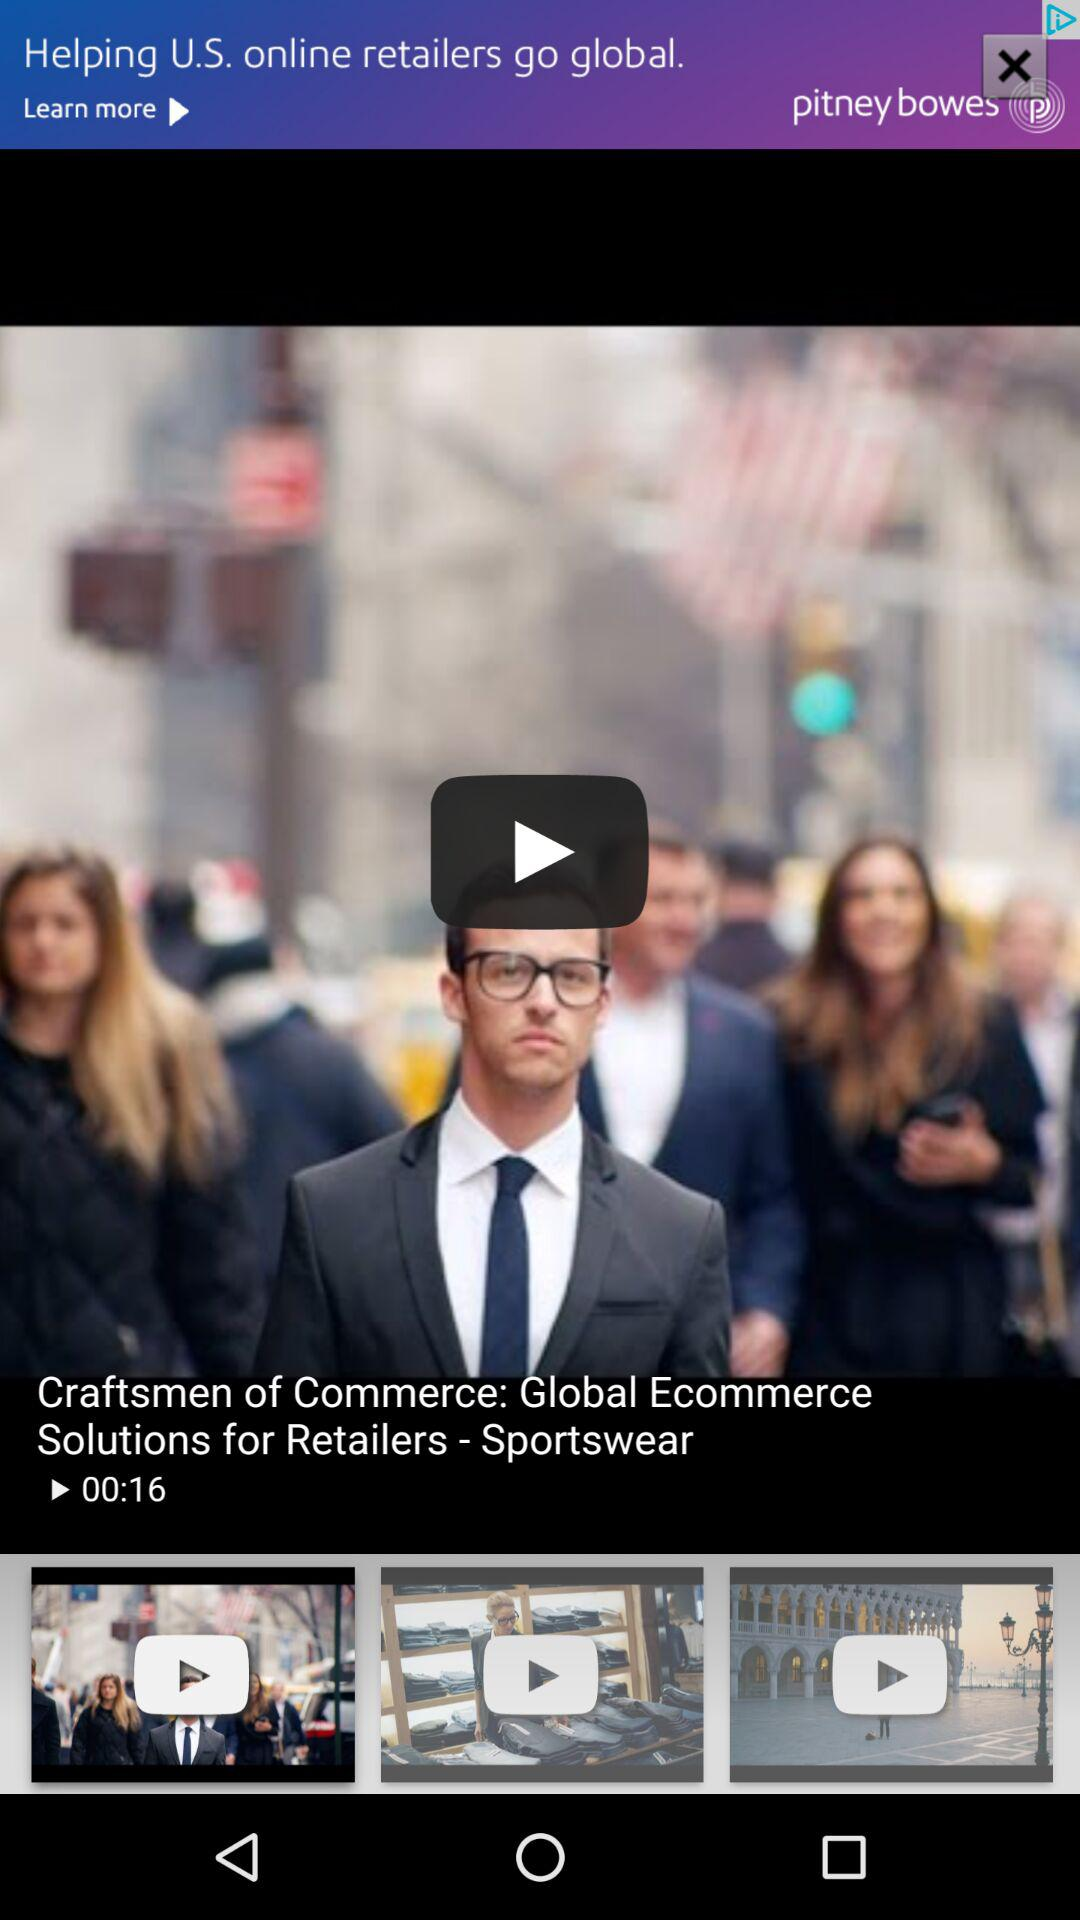When was the video posted?
When the provided information is insufficient, respond with <no answer>. <no answer> 